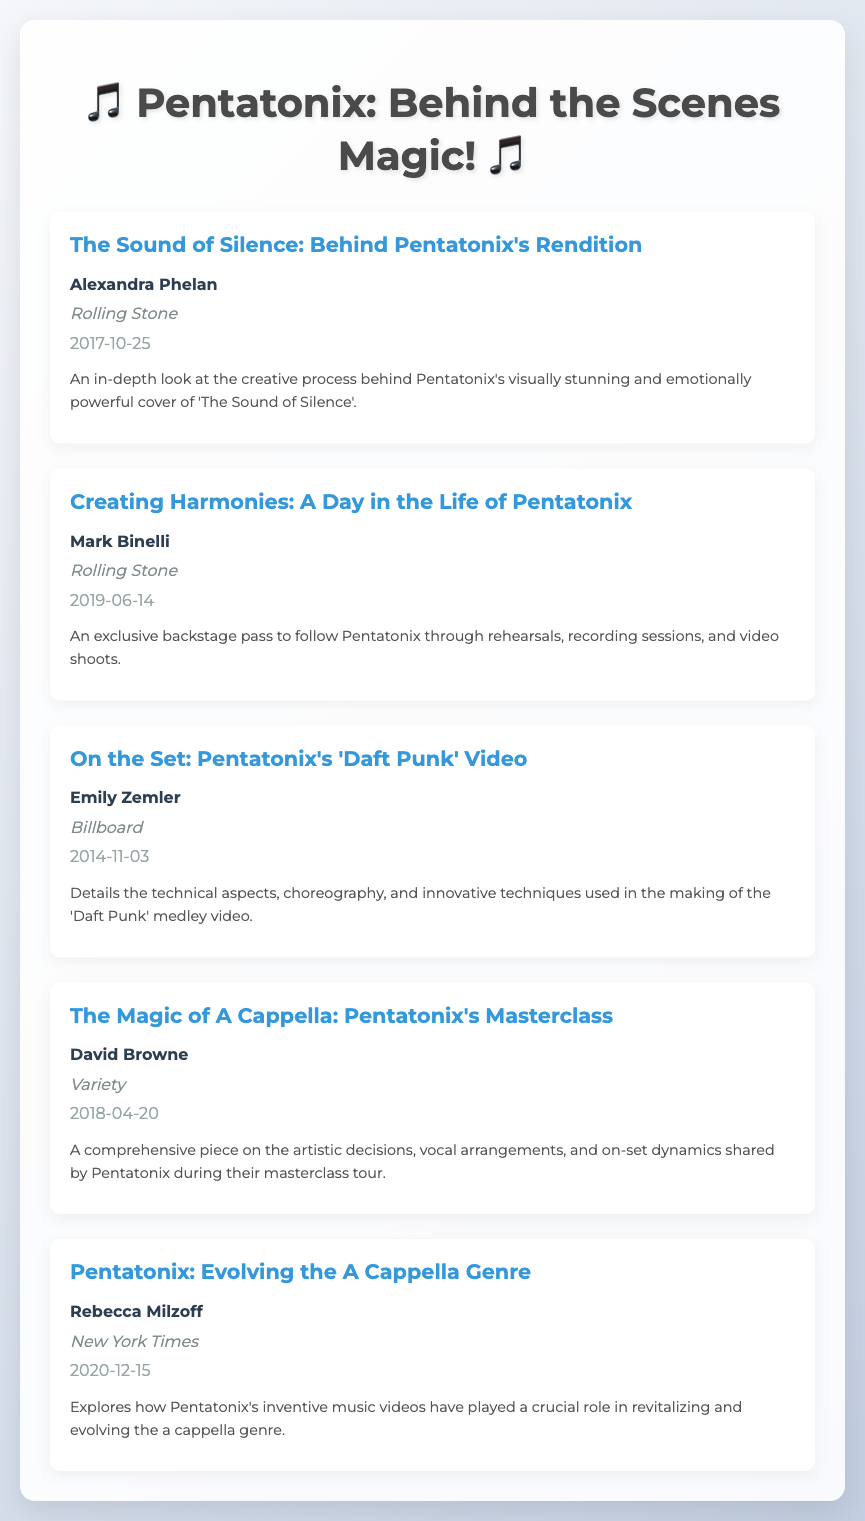what is the title of the first entry? The title of the first entry is found at the top of the entry and is "The Sound of Silence: Behind Pentatonix's Rendition".
Answer: The Sound of Silence: Behind Pentatonix's Rendition who is the author of "Creating Harmonies: A Day in the Life of Pentatonix"? The author's name is listed under the title of the entry for "Creating Harmonies: A Day in the Life of Pentatonix", which is Mark Binelli.
Answer: Mark Binelli what publication featured the article "On the Set: Pentatonix's 'Daft Punk' Video"? The publication name is indicated in the source line of the entry, which states it was featured in Billboard.
Answer: Billboard when was "The Magic of A Cappella: Pentatonix's Masterclass" published? The date of publication is provided in the entry, which is April 20, 2018.
Answer: 2018-04-20 which performance does Rebecca Milzoff discuss in her article? The content of the article is summarized in its description, where it discusses Pentatonix's inventive music videos, but the specific performance is not stated, just the overall impact.
Answer: Their inventive music videos how many entries are listed in the bibliography? The total number of entries can be counted, leading to the conclusion that there are five entries in the bibliography.
Answer: 5 which entry focuses on technical aspects and choreography? The description of the entry specifies its focus on technical aspects and choreography, which refers to "On the Set: Pentatonix's 'Daft Punk' Video".
Answer: On the Set: Pentatonix's 'Daft Punk' Video what is the focus area of the article by David Browne? The focus area is given in the description of the entry, which talks about artistic decisions, vocal arrangements, and on-set dynamics during their masterclass tour.
Answer: Artistic decisions, vocal arrangements, and on-set dynamics 